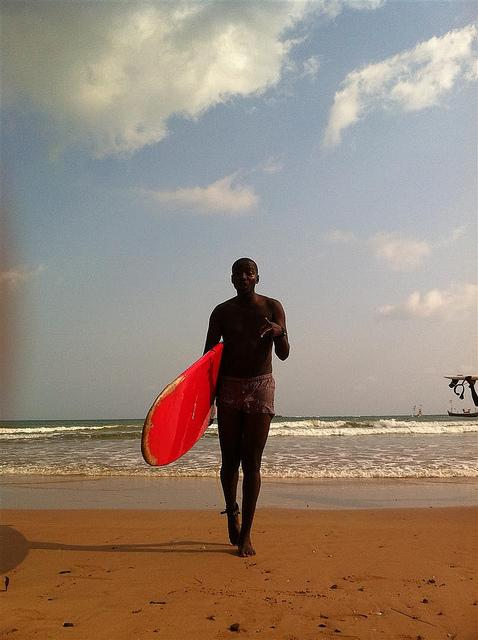What country is this most likely? Please explain your reasoning. jamaica. It seems to be jaimaica because of its weather. 